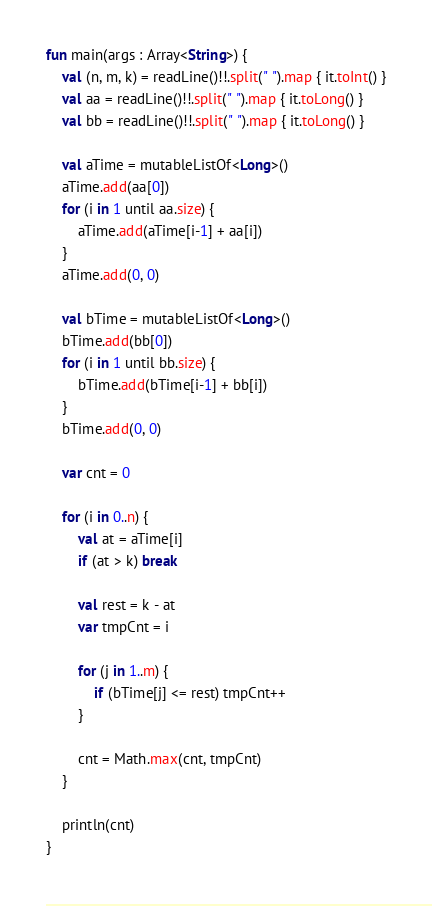Convert code to text. <code><loc_0><loc_0><loc_500><loc_500><_Kotlin_>fun main(args : Array<String>) {
    val (n, m, k) = readLine()!!.split(" ").map { it.toInt() }
    val aa = readLine()!!.split(" ").map { it.toLong() }
    val bb = readLine()!!.split(" ").map { it.toLong() }

    val aTime = mutableListOf<Long>()
    aTime.add(aa[0])
    for (i in 1 until aa.size) {
        aTime.add(aTime[i-1] + aa[i])
    }
    aTime.add(0, 0)

    val bTime = mutableListOf<Long>()
    bTime.add(bb[0])
    for (i in 1 until bb.size) {
        bTime.add(bTime[i-1] + bb[i])
    }
    bTime.add(0, 0)

    var cnt = 0

    for (i in 0..n) {
        val at = aTime[i]
        if (at > k) break

        val rest = k - at
        var tmpCnt = i

        for (j in 1..m) {
            if (bTime[j] <= rest) tmpCnt++
        }

        cnt = Math.max(cnt, tmpCnt)
    }

    println(cnt)
}</code> 